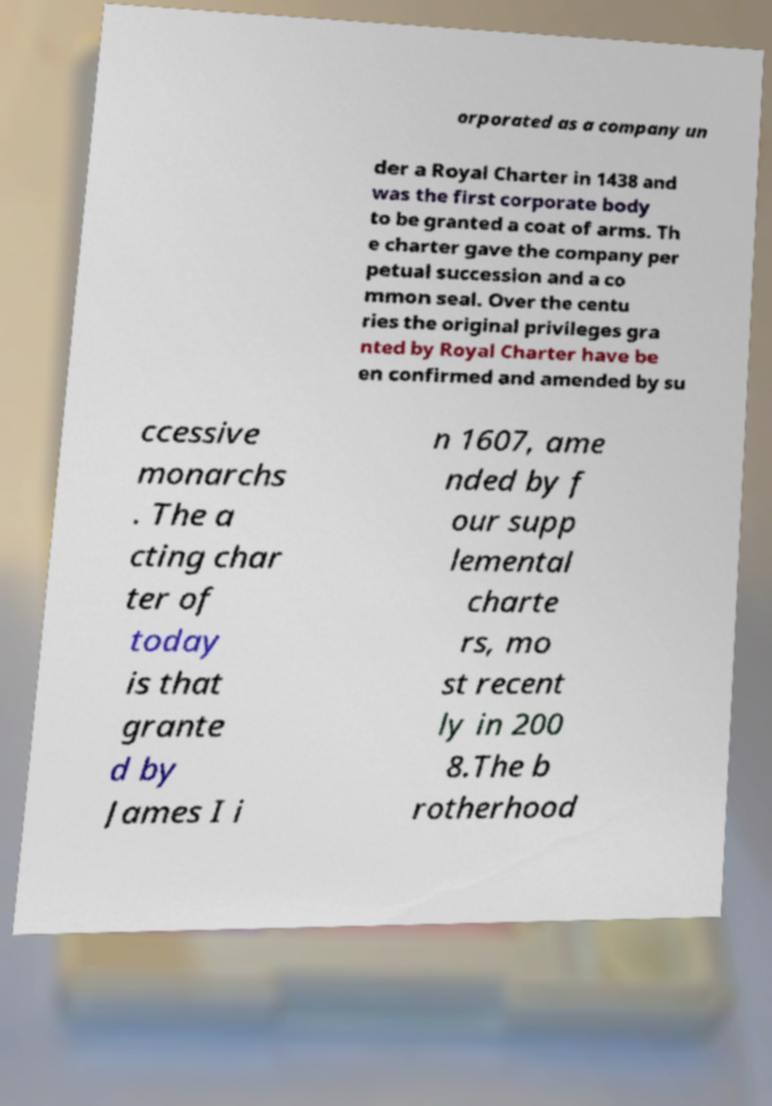Can you read and provide the text displayed in the image?This photo seems to have some interesting text. Can you extract and type it out for me? orporated as a company un der a Royal Charter in 1438 and was the first corporate body to be granted a coat of arms. Th e charter gave the company per petual succession and a co mmon seal. Over the centu ries the original privileges gra nted by Royal Charter have be en confirmed and amended by su ccessive monarchs . The a cting char ter of today is that grante d by James I i n 1607, ame nded by f our supp lemental charte rs, mo st recent ly in 200 8.The b rotherhood 